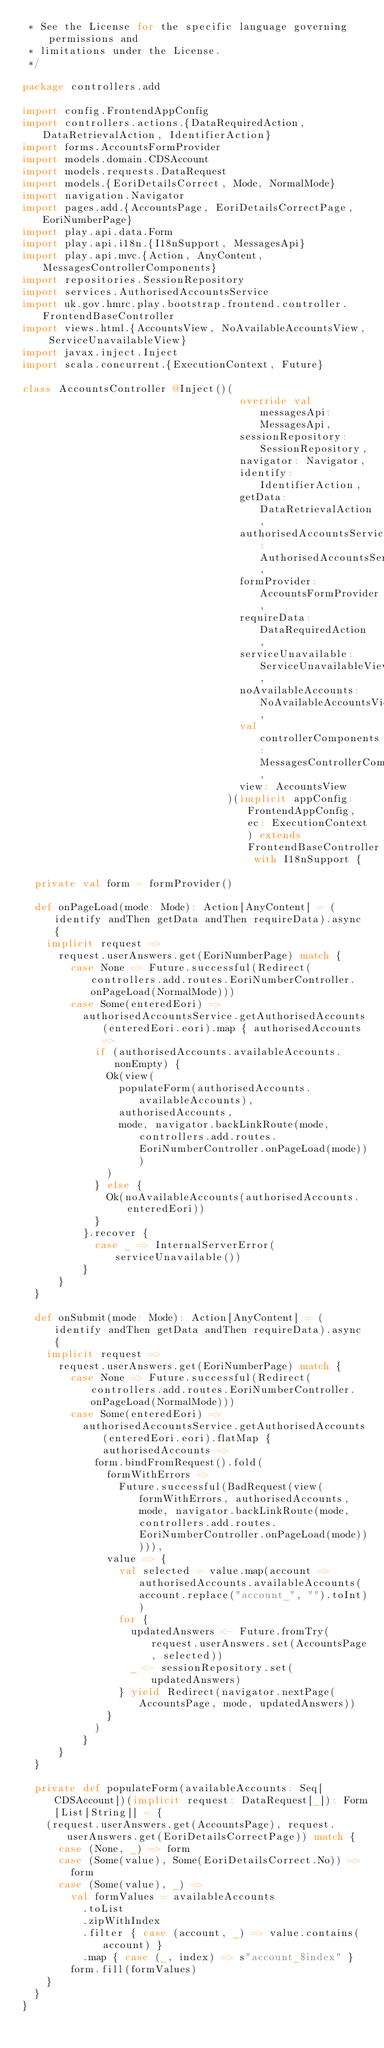<code> <loc_0><loc_0><loc_500><loc_500><_Scala_> * See the License for the specific language governing permissions and
 * limitations under the License.
 */

package controllers.add

import config.FrontendAppConfig
import controllers.actions.{DataRequiredAction, DataRetrievalAction, IdentifierAction}
import forms.AccountsFormProvider
import models.domain.CDSAccount
import models.requests.DataRequest
import models.{EoriDetailsCorrect, Mode, NormalMode}
import navigation.Navigator
import pages.add.{AccountsPage, EoriDetailsCorrectPage, EoriNumberPage}
import play.api.data.Form
import play.api.i18n.{I18nSupport, MessagesApi}
import play.api.mvc.{Action, AnyContent, MessagesControllerComponents}
import repositories.SessionRepository
import services.AuthorisedAccountsService
import uk.gov.hmrc.play.bootstrap.frontend.controller.FrontendBaseController
import views.html.{AccountsView, NoAvailableAccountsView, ServiceUnavailableView}
import javax.inject.Inject
import scala.concurrent.{ExecutionContext, Future}

class AccountsController @Inject()(
                                    override val messagesApi: MessagesApi,
                                    sessionRepository: SessionRepository,
                                    navigator: Navigator,
                                    identify: IdentifierAction,
                                    getData: DataRetrievalAction,
                                    authorisedAccountsService: AuthorisedAccountsService,
                                    formProvider: AccountsFormProvider,
                                    requireData: DataRequiredAction,
                                    serviceUnavailable: ServiceUnavailableView,
                                    noAvailableAccounts: NoAvailableAccountsView,
                                    val controllerComponents: MessagesControllerComponents,
                                    view: AccountsView
                                  )(implicit appConfig: FrontendAppConfig, ec: ExecutionContext) extends FrontendBaseController with I18nSupport {

  private val form = formProvider()

  def onPageLoad(mode: Mode): Action[AnyContent] = (identify andThen getData andThen requireData).async {
    implicit request =>
      request.userAnswers.get(EoriNumberPage) match {
        case None => Future.successful(Redirect(controllers.add.routes.EoriNumberController.onPageLoad(NormalMode)))
        case Some(enteredEori) =>
          authorisedAccountsService.getAuthorisedAccounts(enteredEori.eori).map { authorisedAccounts =>
            if (authorisedAccounts.availableAccounts.nonEmpty) {
              Ok(view(
                populateForm(authorisedAccounts.availableAccounts),
                authorisedAccounts,
                mode, navigator.backLinkRoute(mode, controllers.add.routes.EoriNumberController.onPageLoad(mode)))
              )
            } else {
              Ok(noAvailableAccounts(authorisedAccounts.enteredEori))
            }
          }.recover {
            case _ => InternalServerError(serviceUnavailable())
          }
      }
  }

  def onSubmit(mode: Mode): Action[AnyContent] = (identify andThen getData andThen requireData).async {
    implicit request =>
      request.userAnswers.get(EoriNumberPage) match {
        case None => Future.successful(Redirect(controllers.add.routes.EoriNumberController.onPageLoad(NormalMode)))
        case Some(enteredEori) =>
          authorisedAccountsService.getAuthorisedAccounts(enteredEori.eori).flatMap { authorisedAccounts =>
            form.bindFromRequest().fold(
              formWithErrors =>
                Future.successful(BadRequest(view(formWithErrors, authorisedAccounts, mode, navigator.backLinkRoute(mode, controllers.add.routes.EoriNumberController.onPageLoad(mode))))),
              value => {
                val selected = value.map(account => authorisedAccounts.availableAccounts(account.replace("account_", "").toInt))
                for {
                  updatedAnswers <- Future.fromTry(request.userAnswers.set(AccountsPage, selected))
                  _ <- sessionRepository.set(updatedAnswers)
                } yield Redirect(navigator.nextPage(AccountsPage, mode, updatedAnswers))
              }
            )
          }
      }
  }

  private def populateForm(availableAccounts: Seq[CDSAccount])(implicit request: DataRequest[_]): Form[List[String]] = {
    (request.userAnswers.get(AccountsPage), request.userAnswers.get(EoriDetailsCorrectPage)) match {
      case (None, _) => form
      case (Some(value), Some(EoriDetailsCorrect.No)) =>
        form
      case (Some(value), _) =>
        val formValues = availableAccounts
          .toList
          .zipWithIndex
          .filter { case (account, _) => value.contains(account) }
          .map { case (_, index) => s"account_$index" }
        form.fill(formValues)
    }
  }
}
</code> 